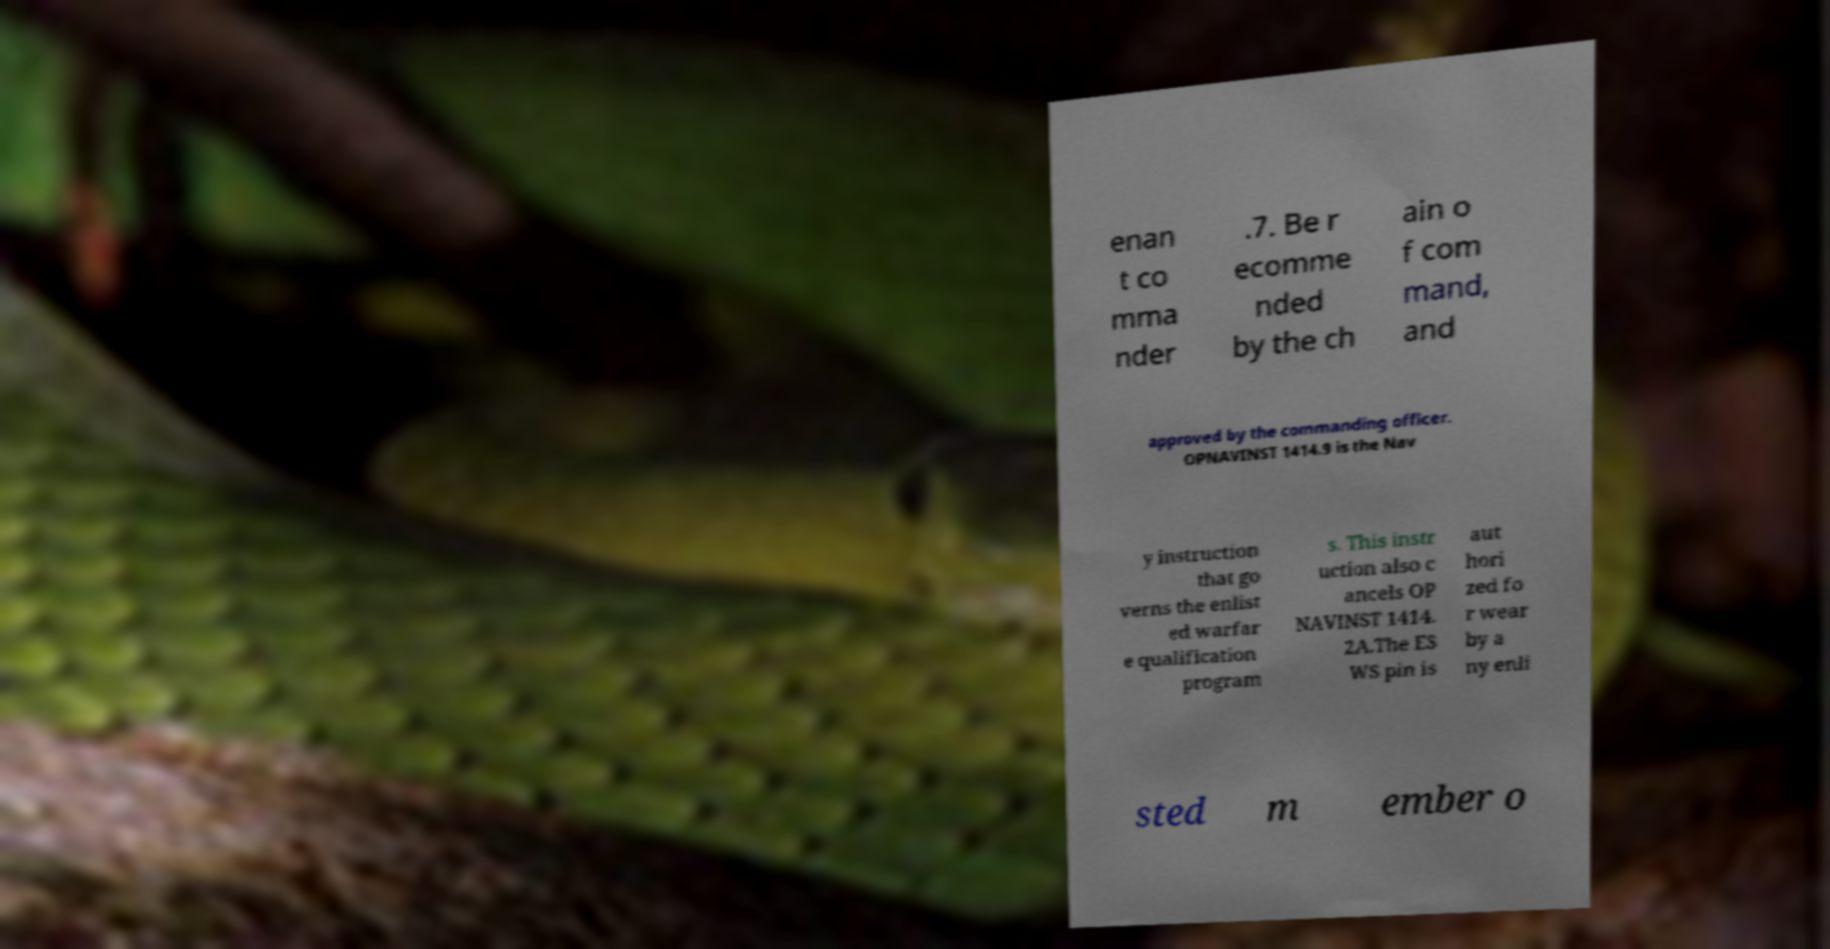Could you extract and type out the text from this image? enan t co mma nder .7. Be r ecomme nded by the ch ain o f com mand, and approved by the commanding officer. OPNAVINST 1414.9 is the Nav y instruction that go verns the enlist ed warfar e qualification program s. This instr uction also c ancels OP NAVINST 1414. 2A.The ES WS pin is aut hori zed fo r wear by a ny enli sted m ember o 